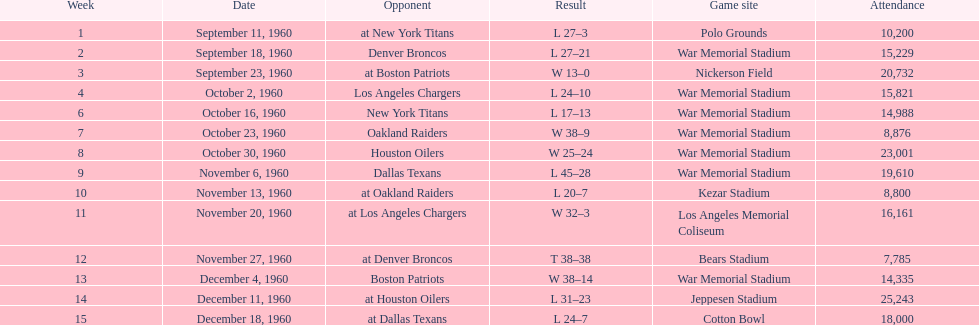What were the total number of games played in november? 4. 